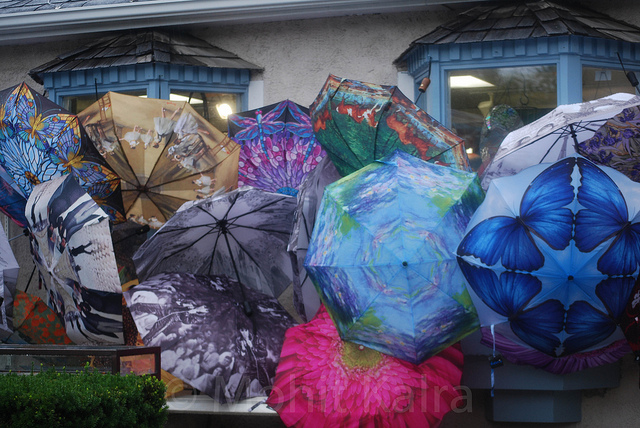Please transcribe the text in this image. balra 